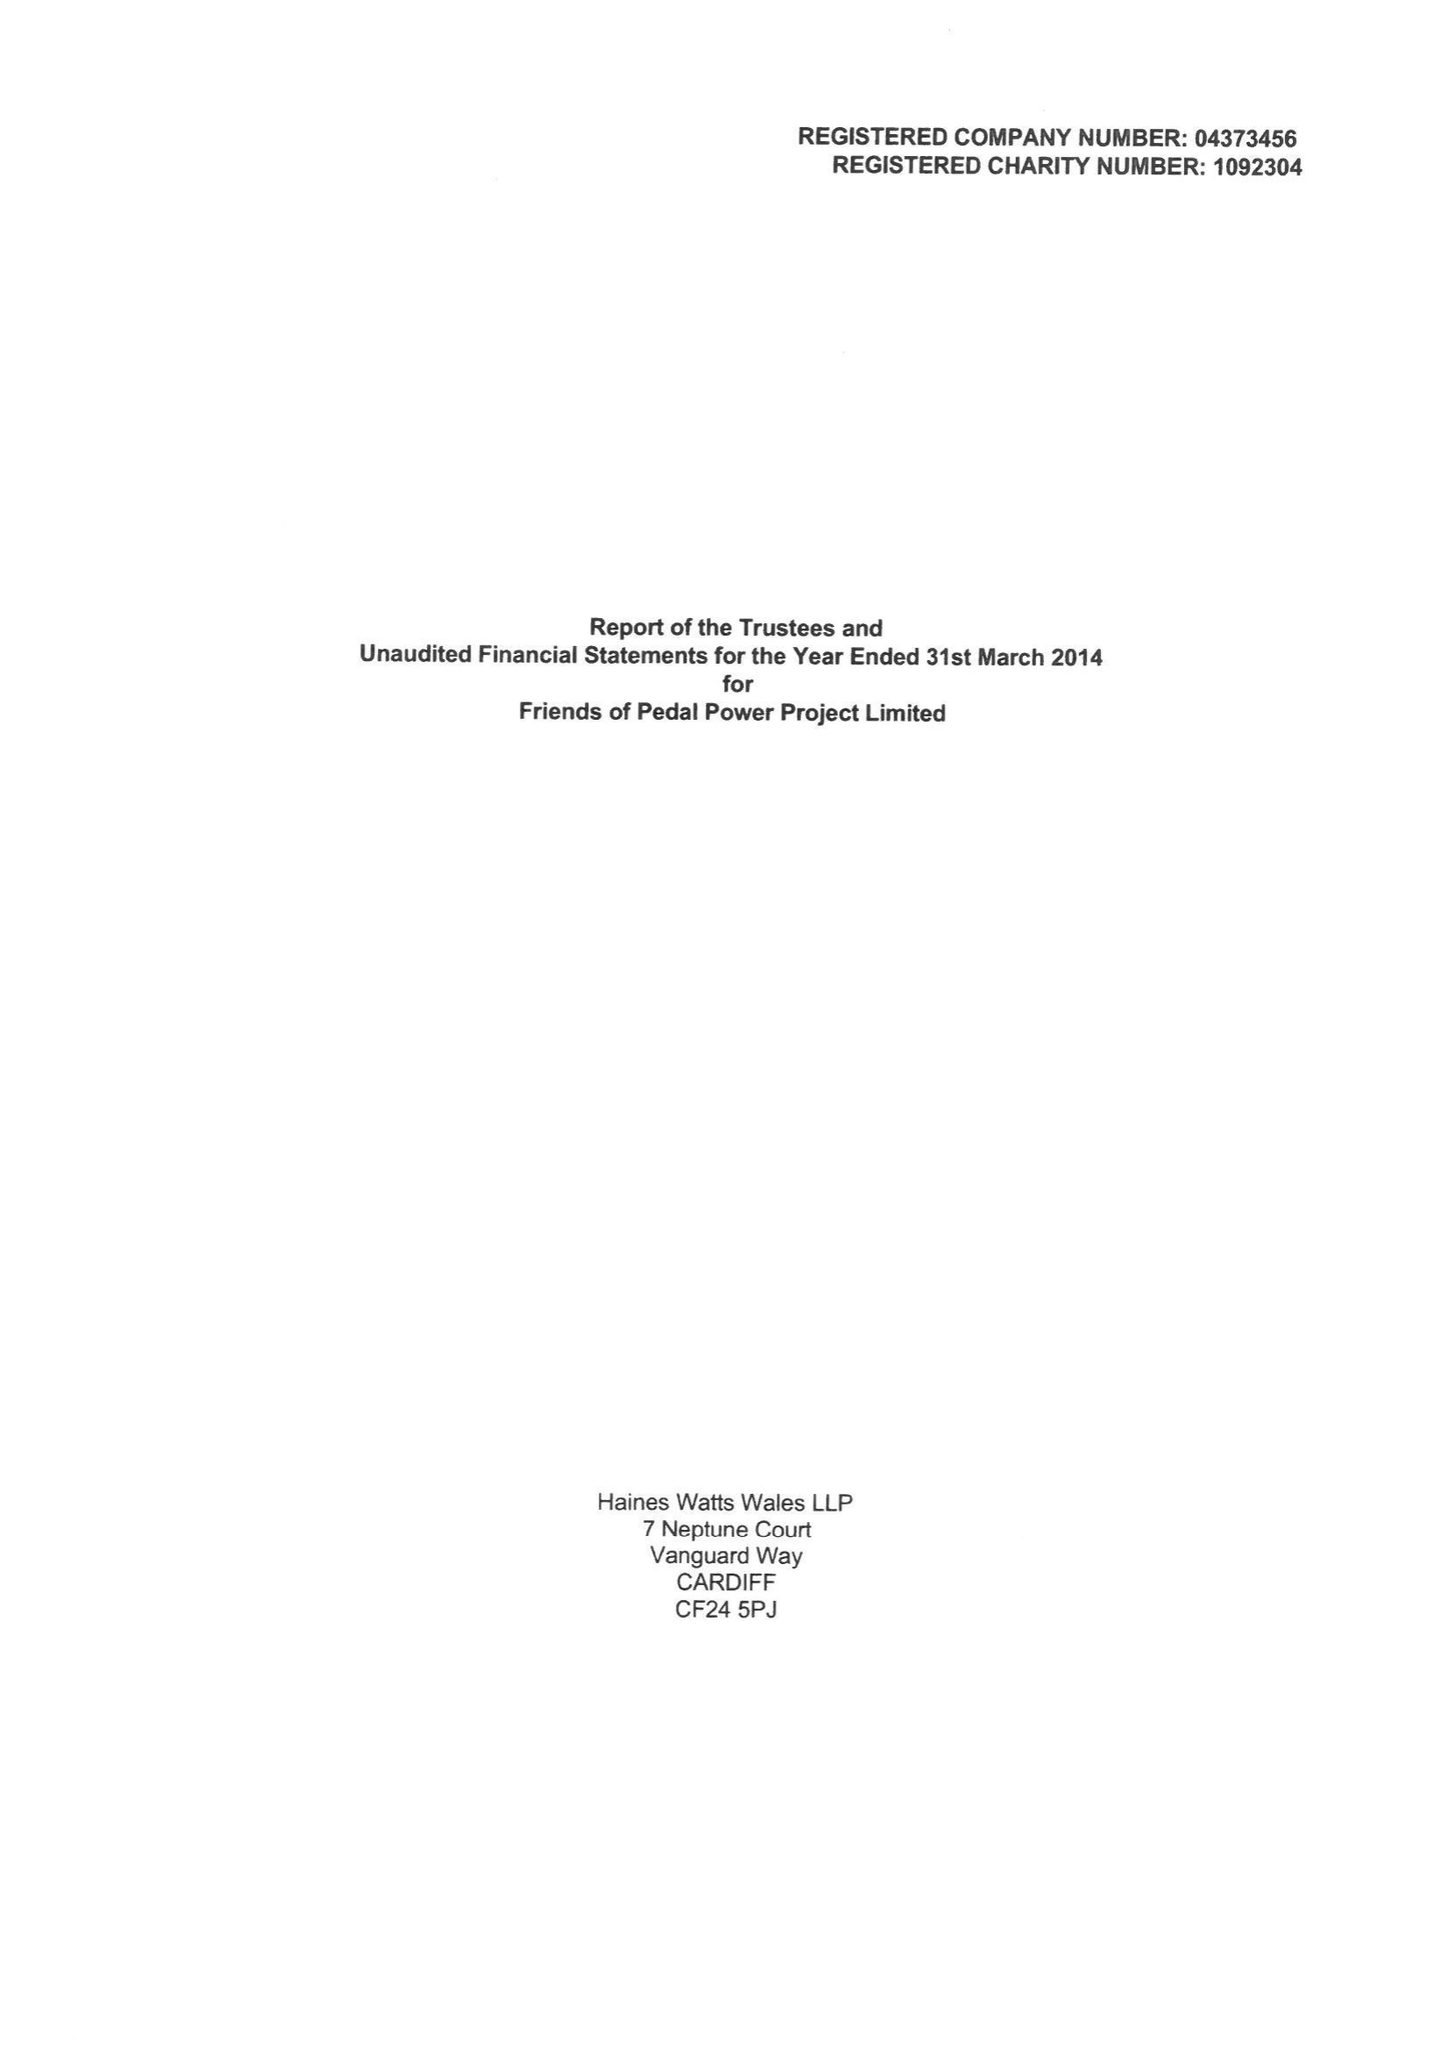What is the value for the report_date?
Answer the question using a single word or phrase. 2014-03-31 